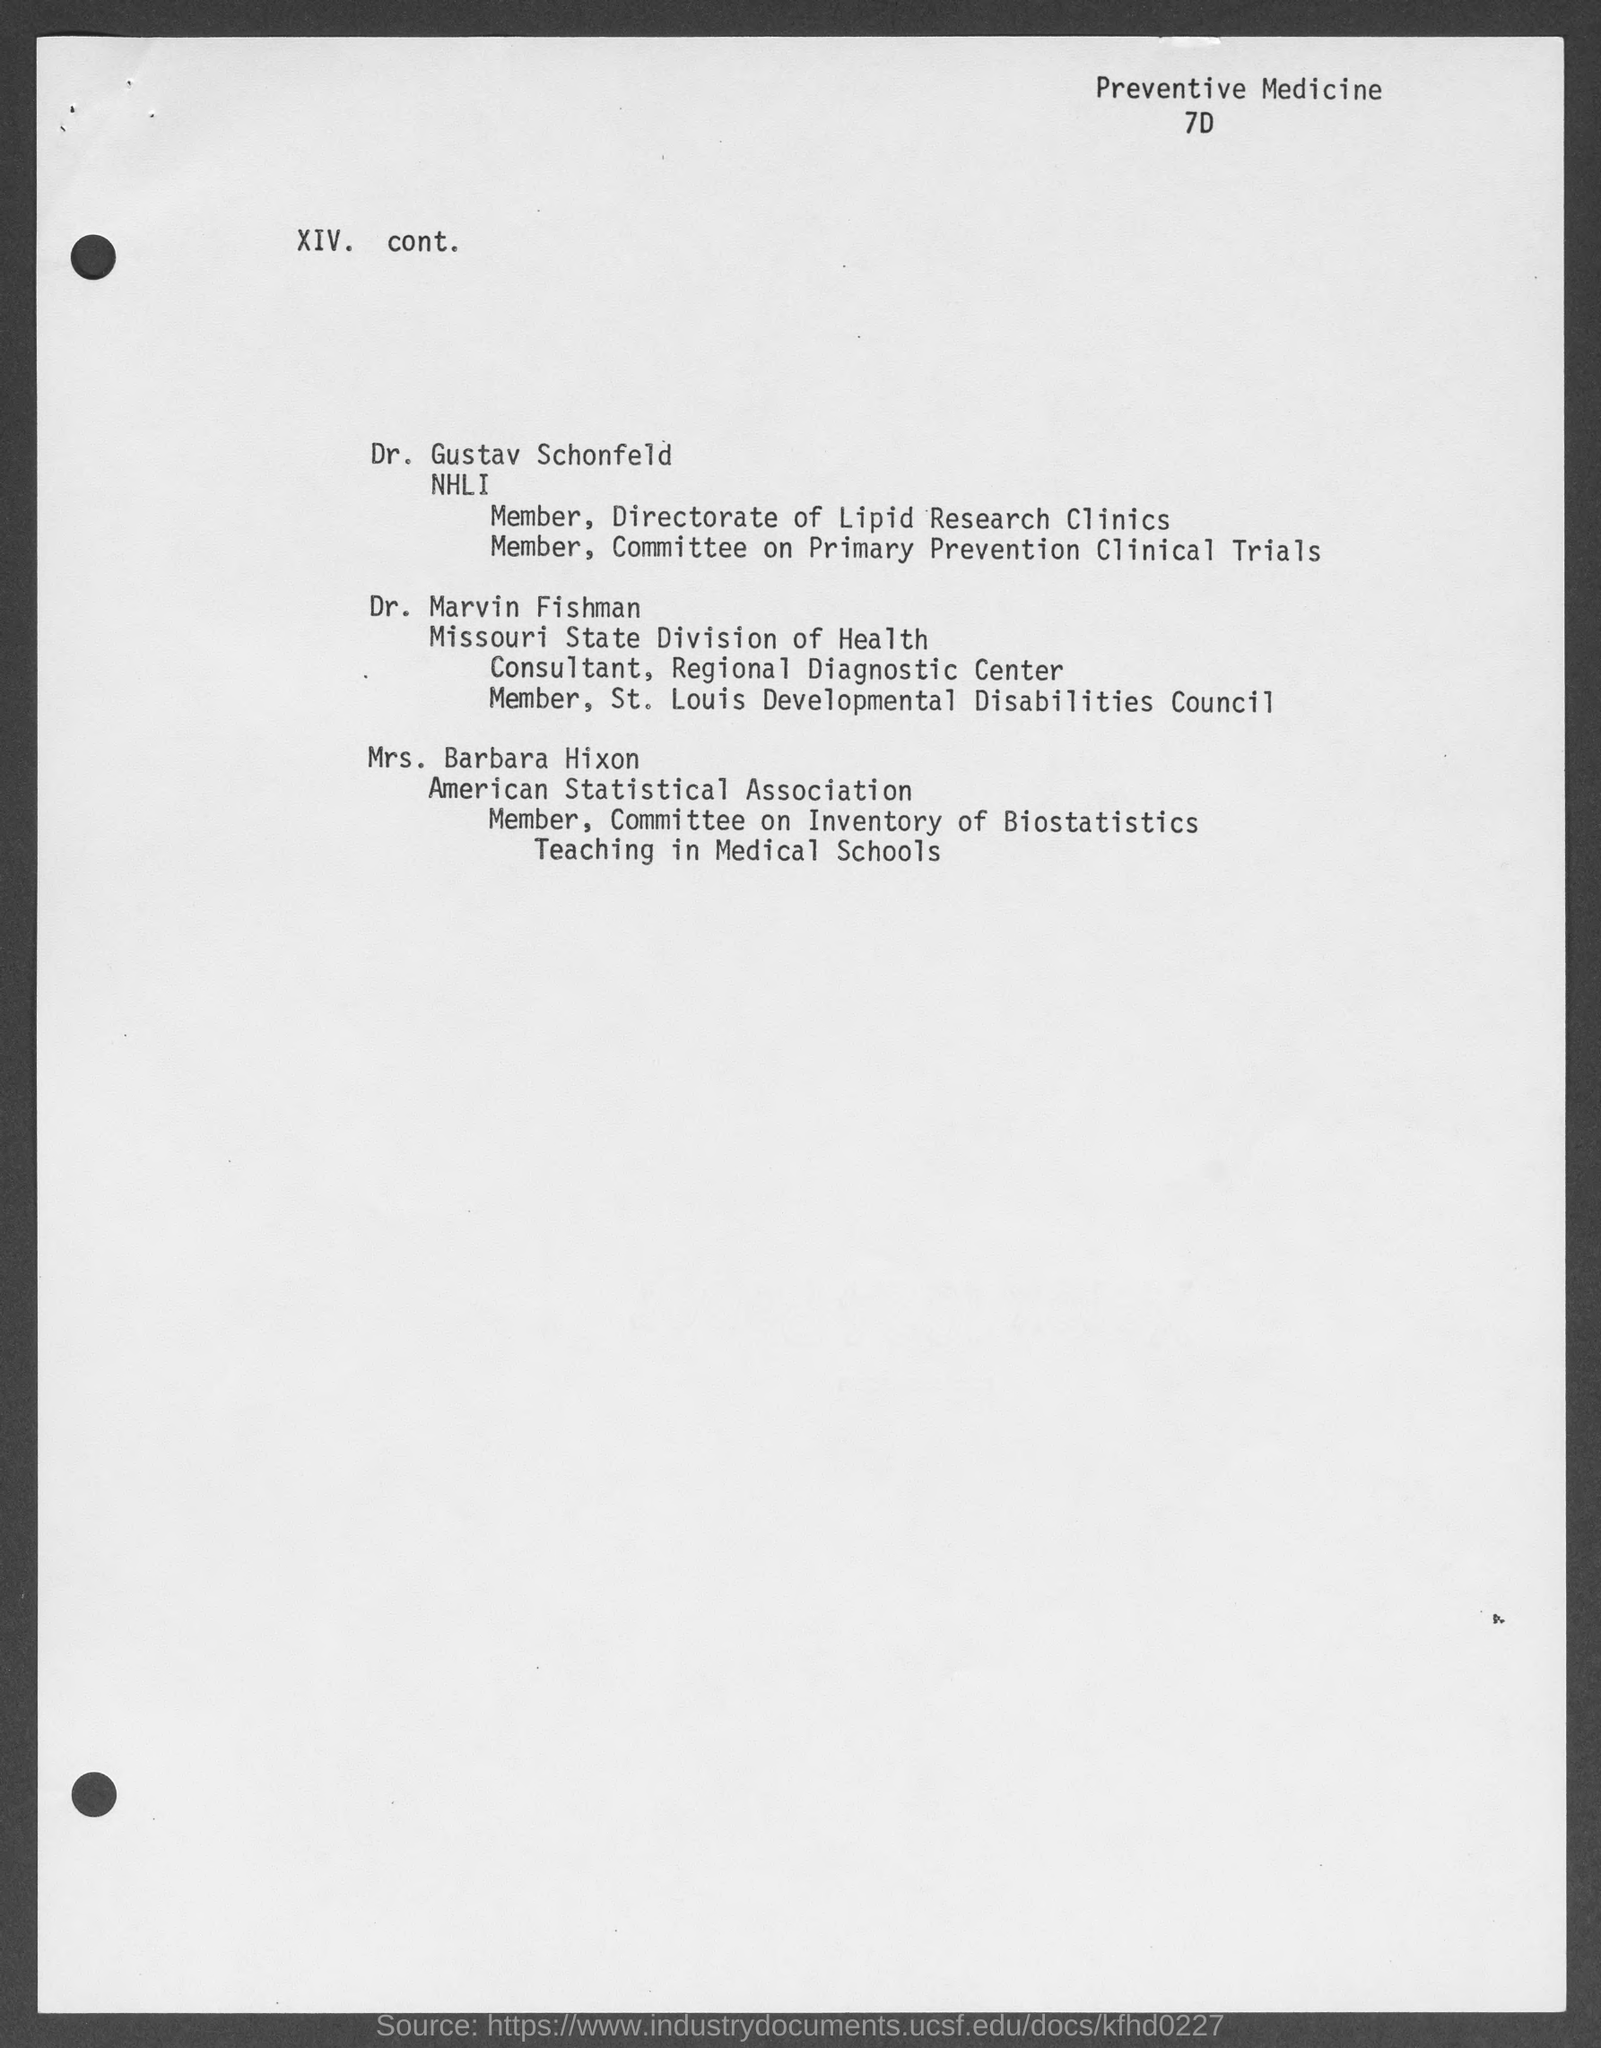List a handful of essential elements in this visual. Mrs. Barbara Hixon is a member of the American Statistical Association. 